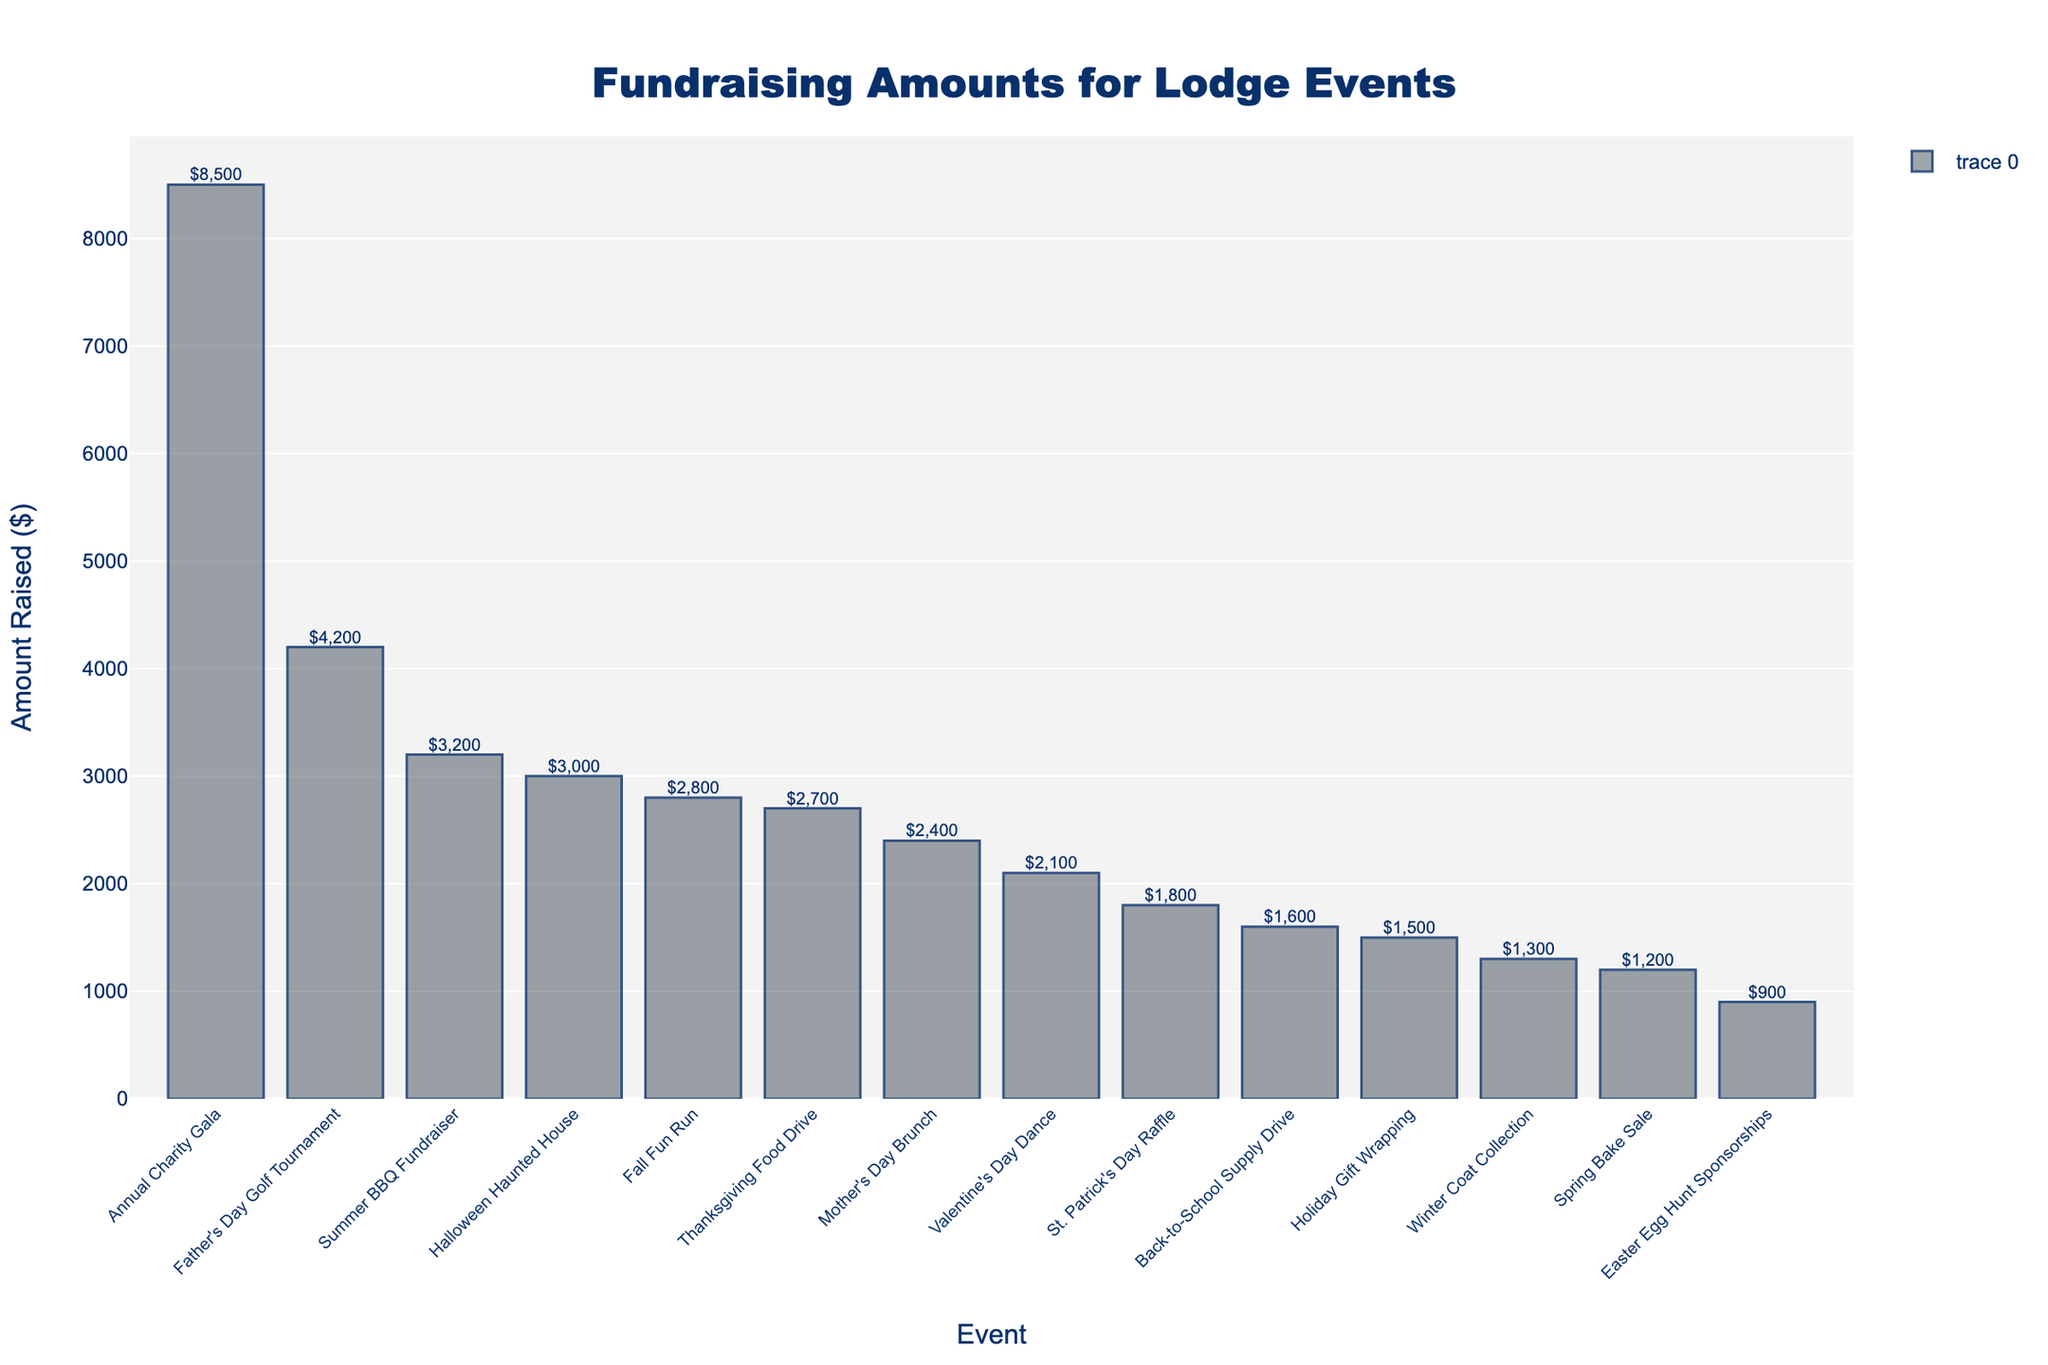Which event raised the most amount of money? The event that raised the most money has the tallest bar in the chart. Identify the tallest bar and find the corresponding event name, which is "Annual Charity Gala" with $8500.
Answer: Annual Charity Gala Which event raised the least amount of money? The event that raised the least money has the shortest bar in the chart. Identify the shortest bar and find the corresponding event name, which is "Easter Egg Hunt Sponsorships" with $900.
Answer: Easter Egg Hunt Sponsorships What is the combined amount raised by the Annual Charity Gala and the Summer BBQ Fundraiser? Find the amounts raised by the Annual Charity Gala ($8500) and the Summer BBQ Fundraiser ($3200), then add them together: $8500 + $3200 = $11700.
Answer: $11700 How much more did the Father’s Day Golf Tournament raise compared to the Spring Bake Sale? Find the amounts raised by the Father's Day Golf Tournament ($4200) and the Spring Bake Sale ($1200), then subtract the smaller amount from the larger one: $4200 - $1200 = $3000.
Answer: $3000 Which event raised the second-highest amount of money? Identify the event with the second tallest bar in the chart, which is the Father’s Day Golf Tournament with $4200.
Answer: Father’s Day Golf Tournament How much more did the Summer BBQ Fundraiser raise than the Holiday Gift Wrapping event? Find the amounts raised by the Summer BBQ Fundraiser ($3200) and the Holiday Gift Wrapping event ($1500), then subtract the smaller amount from the larger one: $3200 - $1500 = $1700.
Answer: $1700 What is the average amount raised by the top three fundraising events? Identify the top three events by height: Annual Charity Gala ($8500), Father’s Day Golf Tournament ($4200), and Summer BBQ Fundraiser ($3200). Add the amounts and divide by 3: ($8500 + $4200 + $3200) / 3 = $5300.
Answer: $5300 Which event raised more money: the Valentine’s Day Dance or the Halloween Haunted House? Compare the heights of the bars for the Valentine’s Day Dance ($2100) and the Halloween Haunted House ($3000). The taller bar corresponds to the Halloween Haunted House.
Answer: Halloween Haunted House How much did events in the Spring (Spring Bake Sale, Easter Egg Hunt Sponsorships, Mother’s Day Brunch) collectively raise? Sum the amounts raised by the Spring Bake Sale ($1200), Easter Egg Hunt Sponsorships ($900), and Mother’s Day Brunch ($2400): $1200 + $900 + $2400 = $4500.
Answer: $4500 What is the difference in amount raised between the top fundraising event and the average amount raised by all events? Calculate the average amount raised by all events. First, sum all amounts: $8500 + $1200 + $3200 + $2800 + $1500 + $2100 + $1800 + $900 + $2400 + $4200 + $1600 + $3000 + $2700 + $1300 = $39600. Then, find the average: $39600 / 14 ≈ $2829. The top event (Annual Charity Gala) raised $8500. The difference is: $8500 - $2829 ≈ $5671.
Answer: $5671 